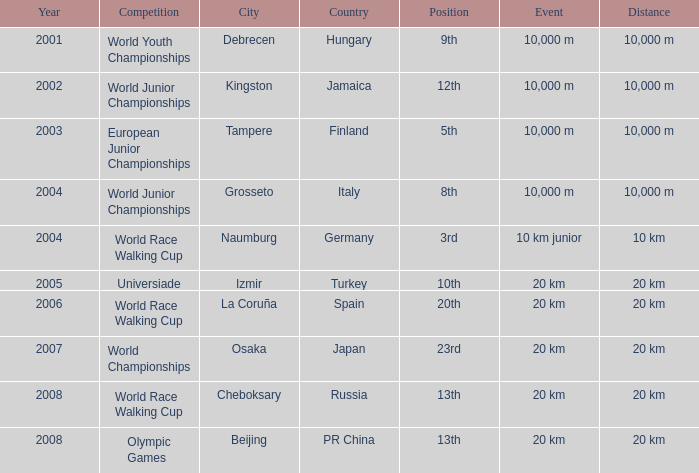In which year did he compete in the Universiade? 2005.0. 